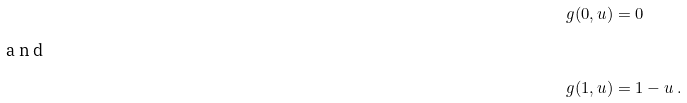<formula> <loc_0><loc_0><loc_500><loc_500>g ( 0 , u ) & = 0 \\ \intertext { a n d } g ( 1 , u ) & = 1 - u \ .</formula> 